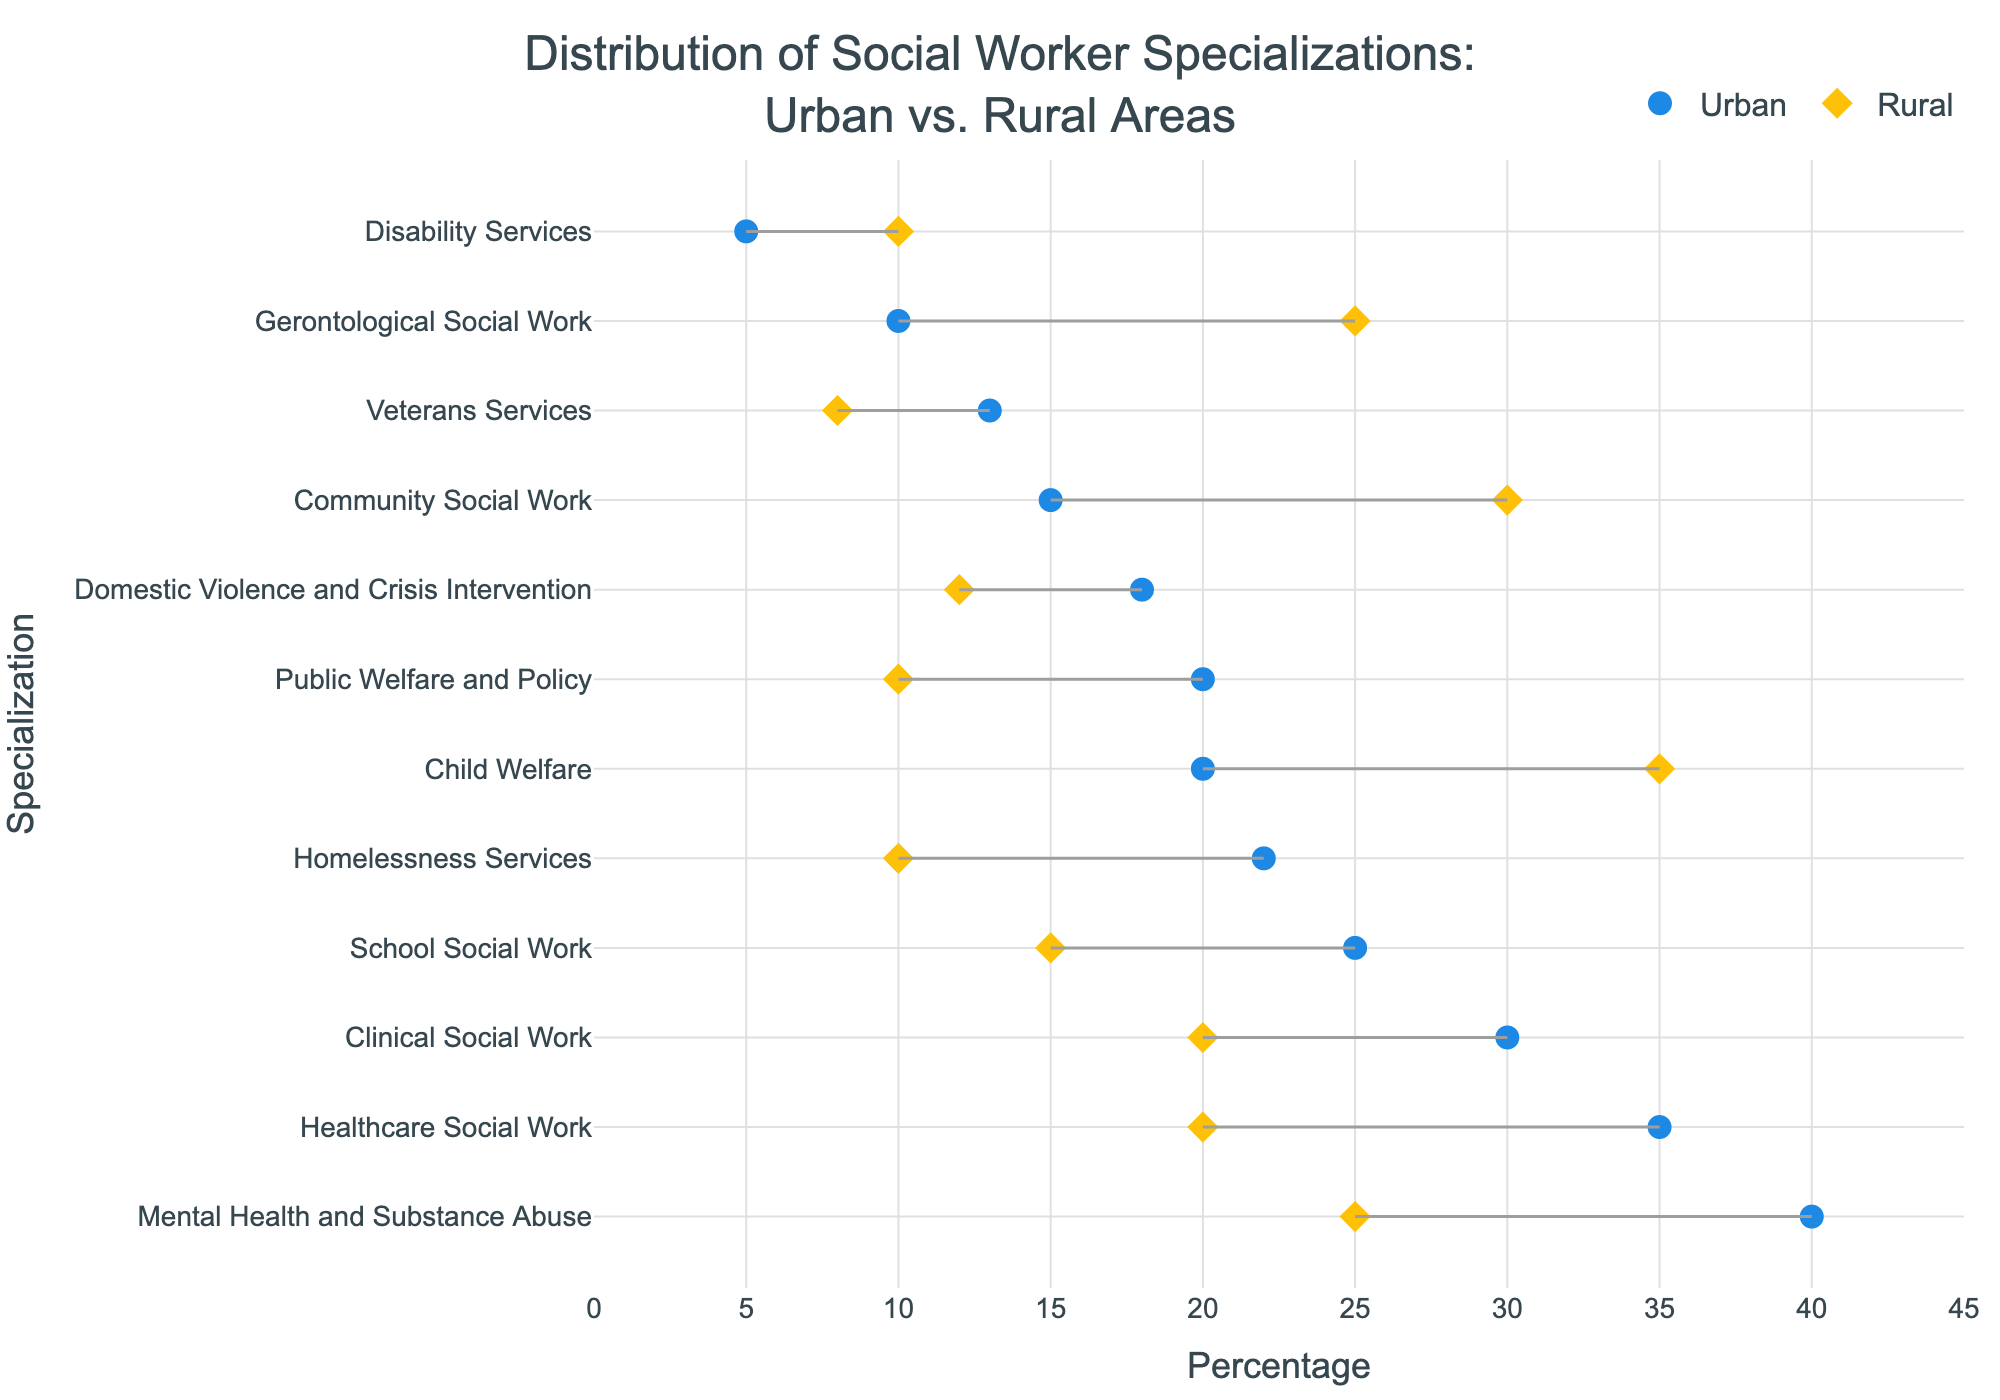What is the title of the figure? The title of the figure is placed at the top and reads, "Distribution of Social Worker Specializations: Urban vs. Rural Areas".
Answer: Distribution of Social Worker Specializations: Urban vs. Rural Areas Which specialization has the highest percentage in urban areas? The specialization with the highest percentage in urban areas is indicated by the marker that is farthest to the right on the x-axis for Urban. This specialization is "Mental Health and Substance Abuse".
Answer: Mental Health and Substance Abuse How does the percentage of Community Social Work differ between urban and rural areas? To find the difference, locate the percentages for Community Social Work in both urban and rural areas. Subtract the Rural Percentage (30) from the Urban Percentage (15).
Answer: -15 What specializations have a higher percentage in rural areas than urban areas? Compare the positions of the markers representing rural and urban percentages for each specialization. Those with rural marker further right than urban include Child Welfare, Community Social Work, Gerontological Social Work, and Disability Services.
Answer: Child Welfare, Community Social Work, Gerontological Social Work, Disability Services What is the range of the Healthcare Social Work specialization between urban and rural areas? The range is calculated by subtracting the Rural Percentage (20) from the Urban Percentage (35).
Answer: 15 Which specialization shows the smallest difference between urban and rural percentages? Find the pair of markers with the shortest connecting line. This is "Veterans Services" with a small difference between its urban (13) and rural (8) percentages.
Answer: Veterans Services Are there any specializations where the percentage in urban areas is equal to the percentage in rural areas? Look for any specializations where the markers overlap exactly for urban and rural percentages. There are no specializations where the percentages are equal.
Answer: No Which specialization has the second highest percentage in rural areas? Sort the rural percentages in descending order and find the second one. "Community Social Work" has the second highest rural percentage at 30, after "Child Welfare" at 35.
Answer: Community Social Work 